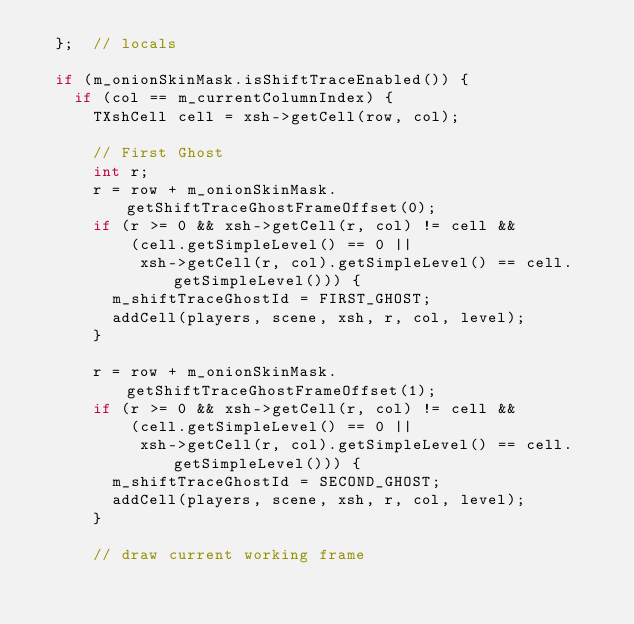<code> <loc_0><loc_0><loc_500><loc_500><_C++_>  };  // locals

  if (m_onionSkinMask.isShiftTraceEnabled()) {
    if (col == m_currentColumnIndex) {
      TXshCell cell = xsh->getCell(row, col);

      // First Ghost
      int r;
      r = row + m_onionSkinMask.getShiftTraceGhostFrameOffset(0);
      if (r >= 0 && xsh->getCell(r, col) != cell &&
          (cell.getSimpleLevel() == 0 ||
           xsh->getCell(r, col).getSimpleLevel() == cell.getSimpleLevel())) {
        m_shiftTraceGhostId = FIRST_GHOST;
        addCell(players, scene, xsh, r, col, level);
      }

      r = row + m_onionSkinMask.getShiftTraceGhostFrameOffset(1);
      if (r >= 0 && xsh->getCell(r, col) != cell &&
          (cell.getSimpleLevel() == 0 ||
           xsh->getCell(r, col).getSimpleLevel() == cell.getSimpleLevel())) {
        m_shiftTraceGhostId = SECOND_GHOST;
        addCell(players, scene, xsh, r, col, level);
      }

      // draw current working frame</code> 